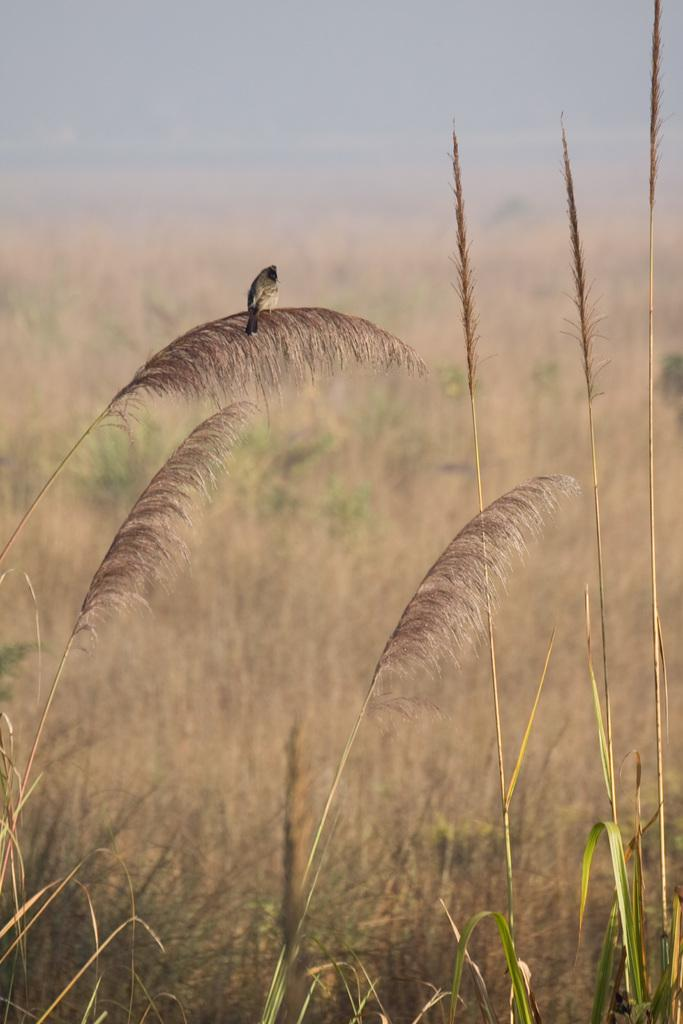What type of animal can be seen in the image? There is a bird in the image. Where is the bird located? The bird is on a plant. What type of vegetation is at the bottom of the image? There is grass at the bottom of the image. What can be seen in the background of the image? There is a field in the background of the image. How many ants are crawling on the bird in the image? There are no ants present in the image; it only features a bird on a plant. What type of chicken is visible in the image? There is no chicken present in the image; it only features a bird on a plant. 